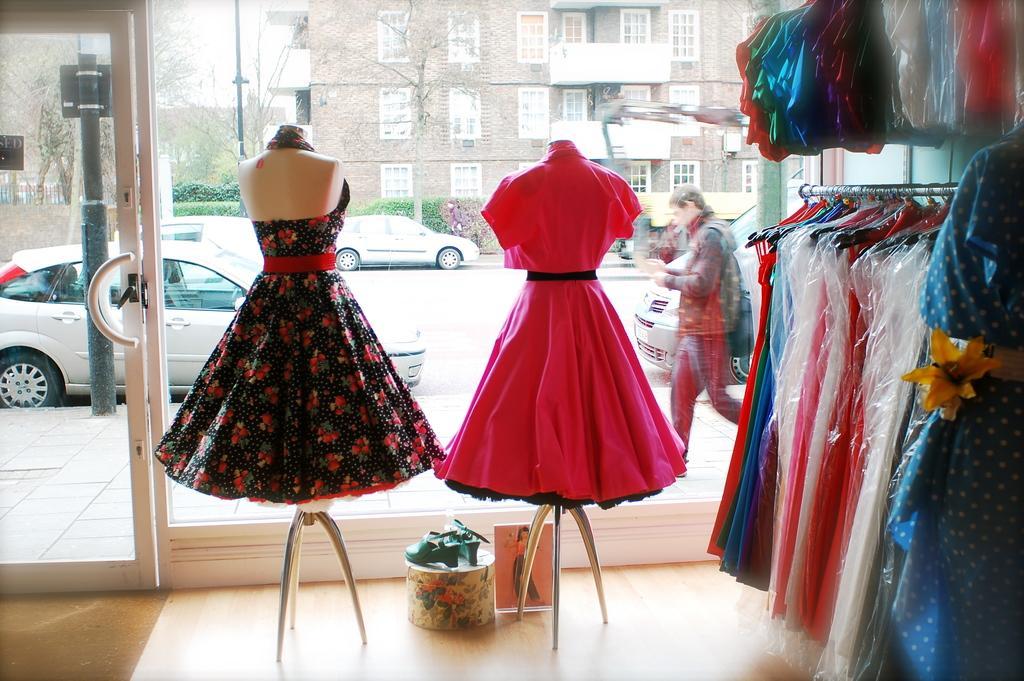How would you summarize this image in a sentence or two? In the center of the image we can see clothes, hangers, glass and a few other objects. Through the glass, we can see one building, windows, trees, plants, one person is walking and a few vehicles on the road. 